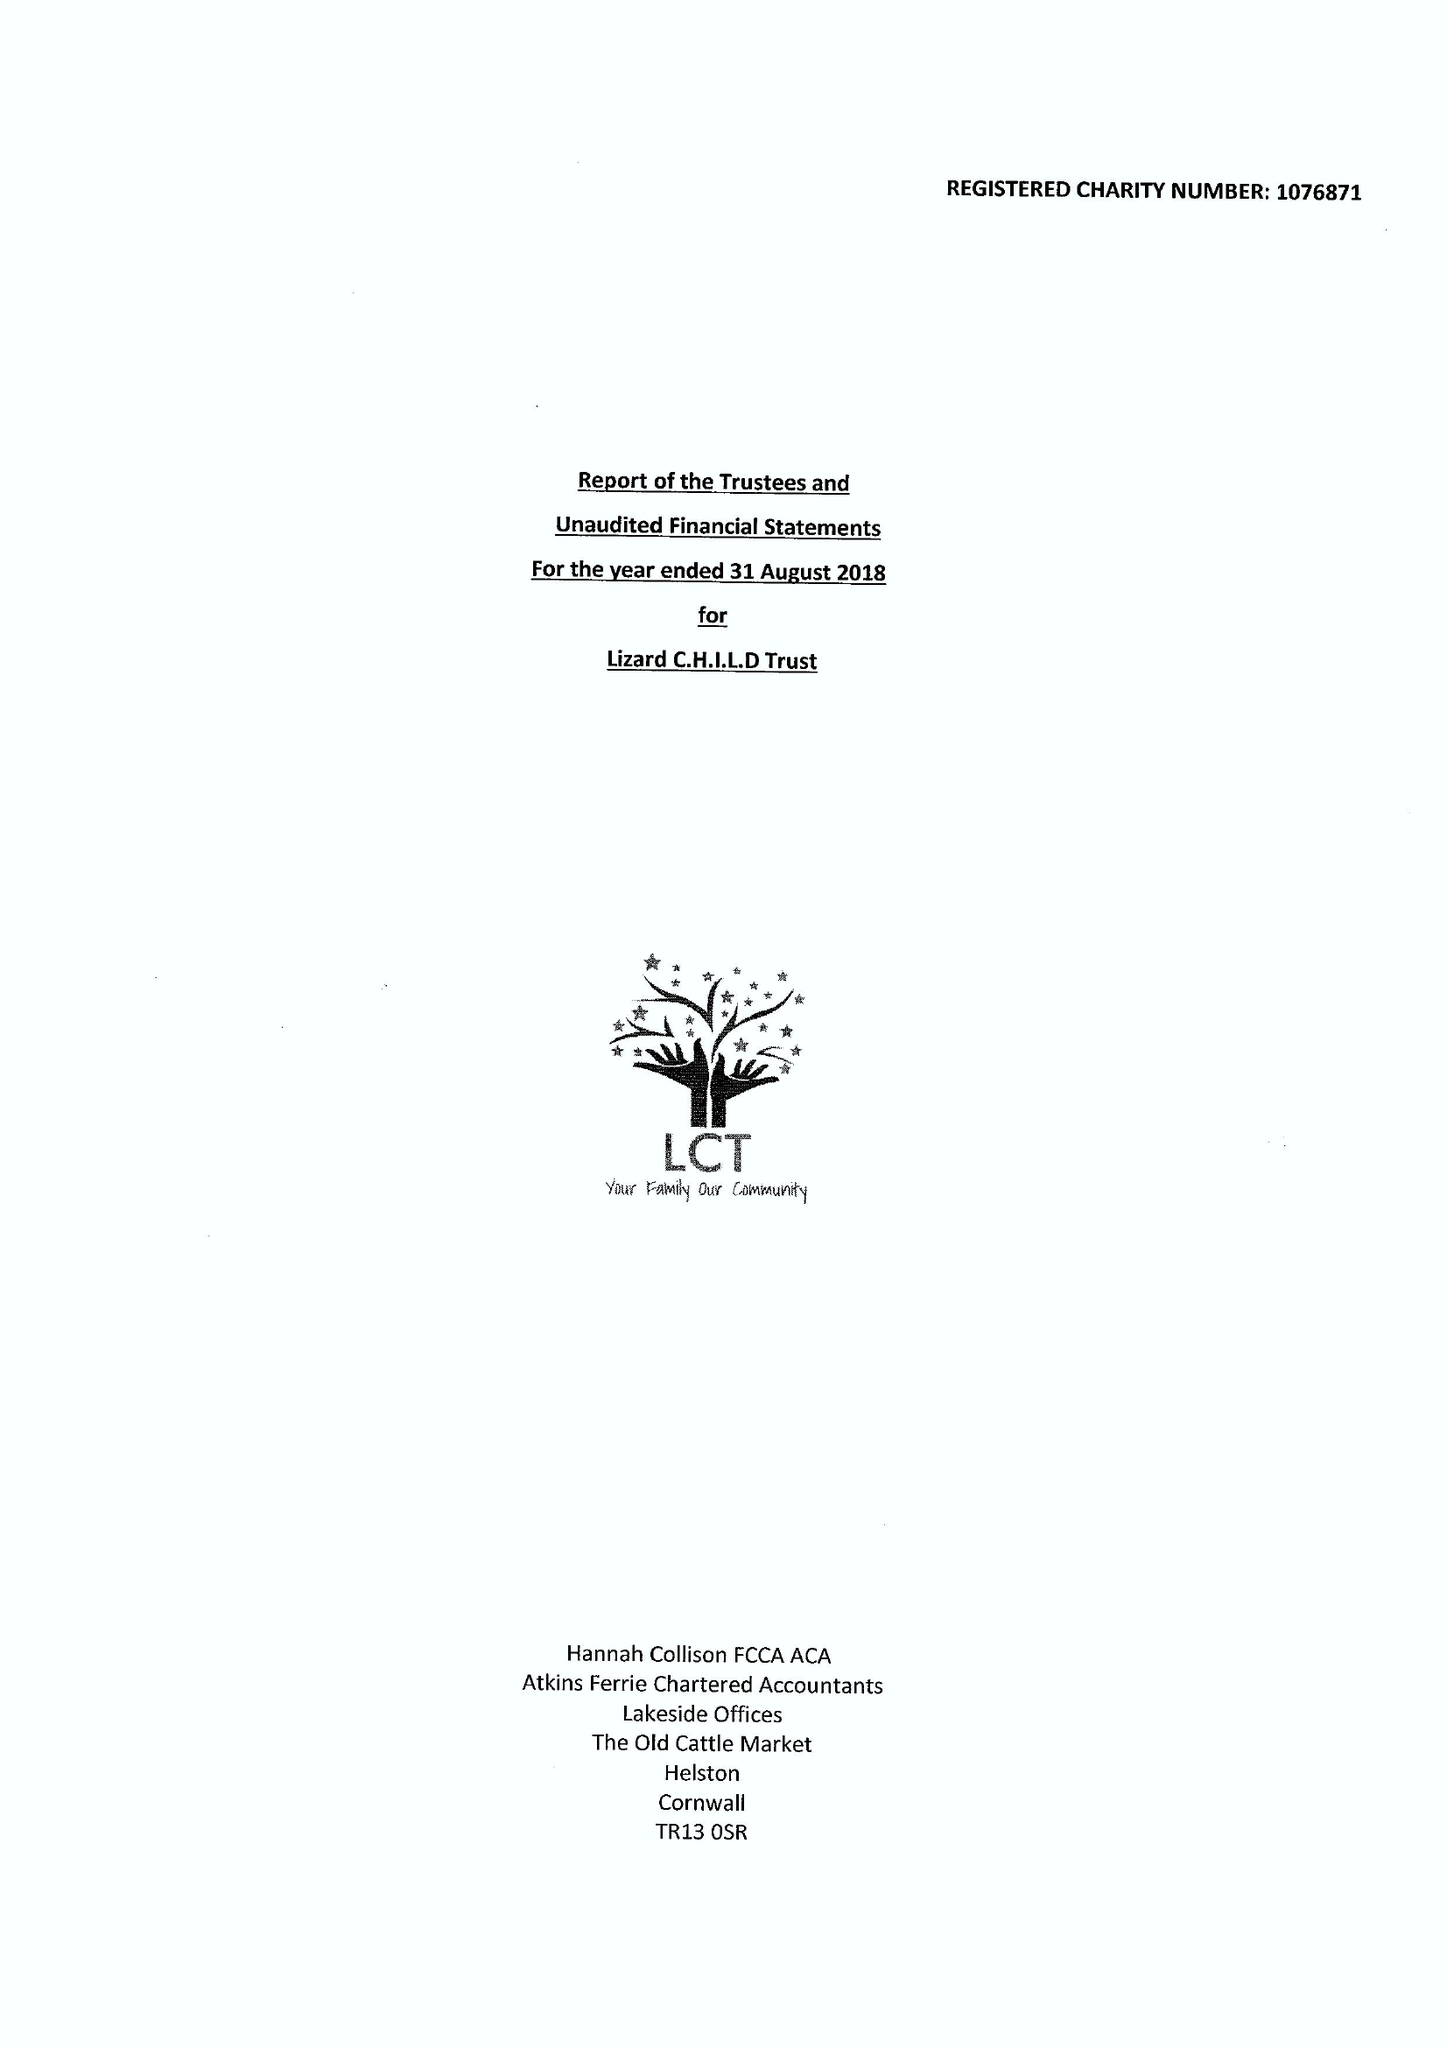What is the value for the address__postcode?
Answer the question using a single word or phrase. TR13 8AR 